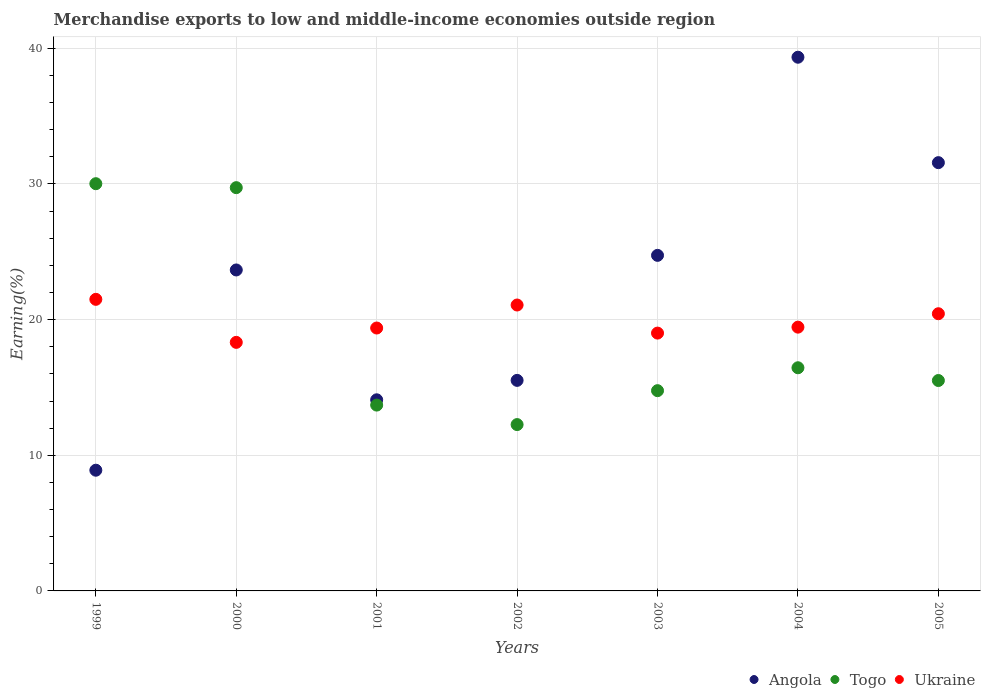How many different coloured dotlines are there?
Ensure brevity in your answer.  3. What is the percentage of amount earned from merchandise exports in Togo in 2002?
Offer a terse response. 12.26. Across all years, what is the maximum percentage of amount earned from merchandise exports in Togo?
Offer a very short reply. 30.02. Across all years, what is the minimum percentage of amount earned from merchandise exports in Togo?
Give a very brief answer. 12.26. In which year was the percentage of amount earned from merchandise exports in Togo minimum?
Give a very brief answer. 2002. What is the total percentage of amount earned from merchandise exports in Angola in the graph?
Make the answer very short. 157.82. What is the difference between the percentage of amount earned from merchandise exports in Togo in 2002 and that in 2003?
Offer a terse response. -2.5. What is the difference between the percentage of amount earned from merchandise exports in Ukraine in 2002 and the percentage of amount earned from merchandise exports in Togo in 2000?
Keep it short and to the point. -8.65. What is the average percentage of amount earned from merchandise exports in Angola per year?
Your response must be concise. 22.55. In the year 2005, what is the difference between the percentage of amount earned from merchandise exports in Angola and percentage of amount earned from merchandise exports in Ukraine?
Your answer should be compact. 11.14. In how many years, is the percentage of amount earned from merchandise exports in Togo greater than 18 %?
Your answer should be very brief. 2. What is the ratio of the percentage of amount earned from merchandise exports in Ukraine in 1999 to that in 2005?
Ensure brevity in your answer.  1.05. Is the percentage of amount earned from merchandise exports in Angola in 2000 less than that in 2002?
Provide a short and direct response. No. What is the difference between the highest and the second highest percentage of amount earned from merchandise exports in Togo?
Provide a short and direct response. 0.29. What is the difference between the highest and the lowest percentage of amount earned from merchandise exports in Ukraine?
Provide a succinct answer. 3.17. In how many years, is the percentage of amount earned from merchandise exports in Togo greater than the average percentage of amount earned from merchandise exports in Togo taken over all years?
Give a very brief answer. 2. Is it the case that in every year, the sum of the percentage of amount earned from merchandise exports in Togo and percentage of amount earned from merchandise exports in Ukraine  is greater than the percentage of amount earned from merchandise exports in Angola?
Give a very brief answer. No. Does the percentage of amount earned from merchandise exports in Ukraine monotonically increase over the years?
Your answer should be very brief. No. Is the percentage of amount earned from merchandise exports in Ukraine strictly greater than the percentage of amount earned from merchandise exports in Angola over the years?
Your answer should be very brief. No. Is the percentage of amount earned from merchandise exports in Angola strictly less than the percentage of amount earned from merchandise exports in Ukraine over the years?
Your answer should be compact. No. How many dotlines are there?
Your answer should be very brief. 3. How many years are there in the graph?
Offer a terse response. 7. What is the difference between two consecutive major ticks on the Y-axis?
Offer a very short reply. 10. How are the legend labels stacked?
Offer a very short reply. Horizontal. What is the title of the graph?
Keep it short and to the point. Merchandise exports to low and middle-income economies outside region. Does "East Asia (developing only)" appear as one of the legend labels in the graph?
Keep it short and to the point. No. What is the label or title of the X-axis?
Keep it short and to the point. Years. What is the label or title of the Y-axis?
Your answer should be compact. Earning(%). What is the Earning(%) in Angola in 1999?
Keep it short and to the point. 8.9. What is the Earning(%) of Togo in 1999?
Make the answer very short. 30.02. What is the Earning(%) in Ukraine in 1999?
Your answer should be very brief. 21.49. What is the Earning(%) of Angola in 2000?
Your response must be concise. 23.66. What is the Earning(%) in Togo in 2000?
Offer a terse response. 29.73. What is the Earning(%) in Ukraine in 2000?
Keep it short and to the point. 18.32. What is the Earning(%) in Angola in 2001?
Ensure brevity in your answer.  14.09. What is the Earning(%) in Togo in 2001?
Your answer should be very brief. 13.7. What is the Earning(%) of Ukraine in 2001?
Provide a succinct answer. 19.38. What is the Earning(%) in Angola in 2002?
Provide a succinct answer. 15.52. What is the Earning(%) in Togo in 2002?
Ensure brevity in your answer.  12.26. What is the Earning(%) of Ukraine in 2002?
Keep it short and to the point. 21.08. What is the Earning(%) of Angola in 2003?
Keep it short and to the point. 24.74. What is the Earning(%) of Togo in 2003?
Make the answer very short. 14.76. What is the Earning(%) in Ukraine in 2003?
Your answer should be compact. 19.01. What is the Earning(%) in Angola in 2004?
Provide a short and direct response. 39.34. What is the Earning(%) of Togo in 2004?
Provide a short and direct response. 16.45. What is the Earning(%) of Ukraine in 2004?
Give a very brief answer. 19.44. What is the Earning(%) of Angola in 2005?
Give a very brief answer. 31.57. What is the Earning(%) in Togo in 2005?
Keep it short and to the point. 15.51. What is the Earning(%) of Ukraine in 2005?
Ensure brevity in your answer.  20.43. Across all years, what is the maximum Earning(%) of Angola?
Offer a very short reply. 39.34. Across all years, what is the maximum Earning(%) of Togo?
Your answer should be compact. 30.02. Across all years, what is the maximum Earning(%) of Ukraine?
Provide a succinct answer. 21.49. Across all years, what is the minimum Earning(%) of Angola?
Your answer should be compact. 8.9. Across all years, what is the minimum Earning(%) in Togo?
Keep it short and to the point. 12.26. Across all years, what is the minimum Earning(%) in Ukraine?
Keep it short and to the point. 18.32. What is the total Earning(%) in Angola in the graph?
Your answer should be compact. 157.82. What is the total Earning(%) of Togo in the graph?
Keep it short and to the point. 132.43. What is the total Earning(%) of Ukraine in the graph?
Provide a succinct answer. 139.16. What is the difference between the Earning(%) in Angola in 1999 and that in 2000?
Offer a very short reply. -14.76. What is the difference between the Earning(%) of Togo in 1999 and that in 2000?
Ensure brevity in your answer.  0.29. What is the difference between the Earning(%) in Ukraine in 1999 and that in 2000?
Offer a terse response. 3.17. What is the difference between the Earning(%) of Angola in 1999 and that in 2001?
Make the answer very short. -5.19. What is the difference between the Earning(%) of Togo in 1999 and that in 2001?
Offer a very short reply. 16.32. What is the difference between the Earning(%) in Ukraine in 1999 and that in 2001?
Ensure brevity in your answer.  2.11. What is the difference between the Earning(%) of Angola in 1999 and that in 2002?
Ensure brevity in your answer.  -6.62. What is the difference between the Earning(%) in Togo in 1999 and that in 2002?
Your answer should be compact. 17.76. What is the difference between the Earning(%) in Ukraine in 1999 and that in 2002?
Offer a very short reply. 0.42. What is the difference between the Earning(%) of Angola in 1999 and that in 2003?
Ensure brevity in your answer.  -15.84. What is the difference between the Earning(%) in Togo in 1999 and that in 2003?
Give a very brief answer. 15.26. What is the difference between the Earning(%) in Ukraine in 1999 and that in 2003?
Ensure brevity in your answer.  2.49. What is the difference between the Earning(%) in Angola in 1999 and that in 2004?
Your answer should be very brief. -30.44. What is the difference between the Earning(%) in Togo in 1999 and that in 2004?
Give a very brief answer. 13.57. What is the difference between the Earning(%) in Ukraine in 1999 and that in 2004?
Ensure brevity in your answer.  2.05. What is the difference between the Earning(%) of Angola in 1999 and that in 2005?
Offer a terse response. -22.67. What is the difference between the Earning(%) of Togo in 1999 and that in 2005?
Give a very brief answer. 14.51. What is the difference between the Earning(%) in Ukraine in 1999 and that in 2005?
Ensure brevity in your answer.  1.06. What is the difference between the Earning(%) in Angola in 2000 and that in 2001?
Offer a very short reply. 9.57. What is the difference between the Earning(%) of Togo in 2000 and that in 2001?
Give a very brief answer. 16.03. What is the difference between the Earning(%) in Ukraine in 2000 and that in 2001?
Ensure brevity in your answer.  -1.06. What is the difference between the Earning(%) in Angola in 2000 and that in 2002?
Your answer should be very brief. 8.14. What is the difference between the Earning(%) of Togo in 2000 and that in 2002?
Your answer should be compact. 17.47. What is the difference between the Earning(%) in Ukraine in 2000 and that in 2002?
Make the answer very short. -2.75. What is the difference between the Earning(%) in Angola in 2000 and that in 2003?
Your response must be concise. -1.08. What is the difference between the Earning(%) of Togo in 2000 and that in 2003?
Offer a very short reply. 14.96. What is the difference between the Earning(%) of Ukraine in 2000 and that in 2003?
Provide a succinct answer. -0.68. What is the difference between the Earning(%) of Angola in 2000 and that in 2004?
Your response must be concise. -15.68. What is the difference between the Earning(%) in Togo in 2000 and that in 2004?
Provide a succinct answer. 13.28. What is the difference between the Earning(%) in Ukraine in 2000 and that in 2004?
Offer a terse response. -1.12. What is the difference between the Earning(%) in Angola in 2000 and that in 2005?
Provide a succinct answer. -7.91. What is the difference between the Earning(%) of Togo in 2000 and that in 2005?
Keep it short and to the point. 14.22. What is the difference between the Earning(%) of Ukraine in 2000 and that in 2005?
Make the answer very short. -2.11. What is the difference between the Earning(%) in Angola in 2001 and that in 2002?
Your answer should be very brief. -1.43. What is the difference between the Earning(%) in Togo in 2001 and that in 2002?
Keep it short and to the point. 1.44. What is the difference between the Earning(%) of Ukraine in 2001 and that in 2002?
Ensure brevity in your answer.  -1.7. What is the difference between the Earning(%) in Angola in 2001 and that in 2003?
Provide a short and direct response. -10.65. What is the difference between the Earning(%) in Togo in 2001 and that in 2003?
Give a very brief answer. -1.06. What is the difference between the Earning(%) in Ukraine in 2001 and that in 2003?
Offer a terse response. 0.37. What is the difference between the Earning(%) in Angola in 2001 and that in 2004?
Offer a terse response. -25.25. What is the difference between the Earning(%) in Togo in 2001 and that in 2004?
Your answer should be very brief. -2.75. What is the difference between the Earning(%) of Ukraine in 2001 and that in 2004?
Your answer should be compact. -0.06. What is the difference between the Earning(%) of Angola in 2001 and that in 2005?
Provide a succinct answer. -17.48. What is the difference between the Earning(%) in Togo in 2001 and that in 2005?
Offer a terse response. -1.81. What is the difference between the Earning(%) in Ukraine in 2001 and that in 2005?
Provide a succinct answer. -1.05. What is the difference between the Earning(%) in Angola in 2002 and that in 2003?
Your response must be concise. -9.22. What is the difference between the Earning(%) in Togo in 2002 and that in 2003?
Give a very brief answer. -2.5. What is the difference between the Earning(%) in Ukraine in 2002 and that in 2003?
Your answer should be compact. 2.07. What is the difference between the Earning(%) in Angola in 2002 and that in 2004?
Offer a terse response. -23.82. What is the difference between the Earning(%) of Togo in 2002 and that in 2004?
Provide a succinct answer. -4.19. What is the difference between the Earning(%) of Ukraine in 2002 and that in 2004?
Your answer should be compact. 1.63. What is the difference between the Earning(%) of Angola in 2002 and that in 2005?
Offer a very short reply. -16.05. What is the difference between the Earning(%) in Togo in 2002 and that in 2005?
Your answer should be compact. -3.25. What is the difference between the Earning(%) in Ukraine in 2002 and that in 2005?
Ensure brevity in your answer.  0.64. What is the difference between the Earning(%) of Angola in 2003 and that in 2004?
Your response must be concise. -14.61. What is the difference between the Earning(%) in Togo in 2003 and that in 2004?
Provide a short and direct response. -1.69. What is the difference between the Earning(%) in Ukraine in 2003 and that in 2004?
Provide a succinct answer. -0.44. What is the difference between the Earning(%) of Angola in 2003 and that in 2005?
Your answer should be compact. -6.83. What is the difference between the Earning(%) in Togo in 2003 and that in 2005?
Provide a succinct answer. -0.75. What is the difference between the Earning(%) of Ukraine in 2003 and that in 2005?
Keep it short and to the point. -1.43. What is the difference between the Earning(%) of Angola in 2004 and that in 2005?
Keep it short and to the point. 7.77. What is the difference between the Earning(%) of Togo in 2004 and that in 2005?
Keep it short and to the point. 0.94. What is the difference between the Earning(%) of Ukraine in 2004 and that in 2005?
Offer a very short reply. -0.99. What is the difference between the Earning(%) in Angola in 1999 and the Earning(%) in Togo in 2000?
Provide a succinct answer. -20.83. What is the difference between the Earning(%) in Angola in 1999 and the Earning(%) in Ukraine in 2000?
Your response must be concise. -9.42. What is the difference between the Earning(%) of Togo in 1999 and the Earning(%) of Ukraine in 2000?
Offer a very short reply. 11.7. What is the difference between the Earning(%) of Angola in 1999 and the Earning(%) of Togo in 2001?
Your response must be concise. -4.8. What is the difference between the Earning(%) of Angola in 1999 and the Earning(%) of Ukraine in 2001?
Your response must be concise. -10.48. What is the difference between the Earning(%) of Togo in 1999 and the Earning(%) of Ukraine in 2001?
Your response must be concise. 10.64. What is the difference between the Earning(%) of Angola in 1999 and the Earning(%) of Togo in 2002?
Make the answer very short. -3.36. What is the difference between the Earning(%) of Angola in 1999 and the Earning(%) of Ukraine in 2002?
Your response must be concise. -12.18. What is the difference between the Earning(%) of Togo in 1999 and the Earning(%) of Ukraine in 2002?
Provide a succinct answer. 8.94. What is the difference between the Earning(%) in Angola in 1999 and the Earning(%) in Togo in 2003?
Offer a terse response. -5.86. What is the difference between the Earning(%) in Angola in 1999 and the Earning(%) in Ukraine in 2003?
Provide a short and direct response. -10.11. What is the difference between the Earning(%) of Togo in 1999 and the Earning(%) of Ukraine in 2003?
Your answer should be compact. 11.01. What is the difference between the Earning(%) of Angola in 1999 and the Earning(%) of Togo in 2004?
Your answer should be compact. -7.55. What is the difference between the Earning(%) of Angola in 1999 and the Earning(%) of Ukraine in 2004?
Your response must be concise. -10.55. What is the difference between the Earning(%) in Togo in 1999 and the Earning(%) in Ukraine in 2004?
Make the answer very short. 10.57. What is the difference between the Earning(%) of Angola in 1999 and the Earning(%) of Togo in 2005?
Keep it short and to the point. -6.61. What is the difference between the Earning(%) in Angola in 1999 and the Earning(%) in Ukraine in 2005?
Your answer should be compact. -11.54. What is the difference between the Earning(%) in Togo in 1999 and the Earning(%) in Ukraine in 2005?
Your response must be concise. 9.59. What is the difference between the Earning(%) in Angola in 2000 and the Earning(%) in Togo in 2001?
Offer a terse response. 9.96. What is the difference between the Earning(%) in Angola in 2000 and the Earning(%) in Ukraine in 2001?
Keep it short and to the point. 4.28. What is the difference between the Earning(%) of Togo in 2000 and the Earning(%) of Ukraine in 2001?
Your answer should be compact. 10.35. What is the difference between the Earning(%) of Angola in 2000 and the Earning(%) of Togo in 2002?
Your response must be concise. 11.4. What is the difference between the Earning(%) of Angola in 2000 and the Earning(%) of Ukraine in 2002?
Your answer should be compact. 2.58. What is the difference between the Earning(%) of Togo in 2000 and the Earning(%) of Ukraine in 2002?
Keep it short and to the point. 8.65. What is the difference between the Earning(%) of Angola in 2000 and the Earning(%) of Togo in 2003?
Make the answer very short. 8.9. What is the difference between the Earning(%) of Angola in 2000 and the Earning(%) of Ukraine in 2003?
Give a very brief answer. 4.65. What is the difference between the Earning(%) of Togo in 2000 and the Earning(%) of Ukraine in 2003?
Offer a terse response. 10.72. What is the difference between the Earning(%) in Angola in 2000 and the Earning(%) in Togo in 2004?
Give a very brief answer. 7.21. What is the difference between the Earning(%) of Angola in 2000 and the Earning(%) of Ukraine in 2004?
Your answer should be very brief. 4.22. What is the difference between the Earning(%) in Togo in 2000 and the Earning(%) in Ukraine in 2004?
Provide a short and direct response. 10.28. What is the difference between the Earning(%) in Angola in 2000 and the Earning(%) in Togo in 2005?
Your answer should be very brief. 8.15. What is the difference between the Earning(%) of Angola in 2000 and the Earning(%) of Ukraine in 2005?
Offer a very short reply. 3.23. What is the difference between the Earning(%) of Togo in 2000 and the Earning(%) of Ukraine in 2005?
Provide a succinct answer. 9.29. What is the difference between the Earning(%) of Angola in 2001 and the Earning(%) of Togo in 2002?
Provide a short and direct response. 1.83. What is the difference between the Earning(%) in Angola in 2001 and the Earning(%) in Ukraine in 2002?
Provide a succinct answer. -6.99. What is the difference between the Earning(%) of Togo in 2001 and the Earning(%) of Ukraine in 2002?
Offer a terse response. -7.38. What is the difference between the Earning(%) in Angola in 2001 and the Earning(%) in Togo in 2003?
Keep it short and to the point. -0.67. What is the difference between the Earning(%) of Angola in 2001 and the Earning(%) of Ukraine in 2003?
Offer a very short reply. -4.92. What is the difference between the Earning(%) in Togo in 2001 and the Earning(%) in Ukraine in 2003?
Your answer should be compact. -5.31. What is the difference between the Earning(%) in Angola in 2001 and the Earning(%) in Togo in 2004?
Keep it short and to the point. -2.36. What is the difference between the Earning(%) of Angola in 2001 and the Earning(%) of Ukraine in 2004?
Ensure brevity in your answer.  -5.36. What is the difference between the Earning(%) of Togo in 2001 and the Earning(%) of Ukraine in 2004?
Ensure brevity in your answer.  -5.75. What is the difference between the Earning(%) of Angola in 2001 and the Earning(%) of Togo in 2005?
Offer a very short reply. -1.42. What is the difference between the Earning(%) in Angola in 2001 and the Earning(%) in Ukraine in 2005?
Give a very brief answer. -6.34. What is the difference between the Earning(%) in Togo in 2001 and the Earning(%) in Ukraine in 2005?
Your answer should be compact. -6.73. What is the difference between the Earning(%) of Angola in 2002 and the Earning(%) of Togo in 2003?
Provide a succinct answer. 0.76. What is the difference between the Earning(%) of Angola in 2002 and the Earning(%) of Ukraine in 2003?
Keep it short and to the point. -3.49. What is the difference between the Earning(%) of Togo in 2002 and the Earning(%) of Ukraine in 2003?
Keep it short and to the point. -6.74. What is the difference between the Earning(%) of Angola in 2002 and the Earning(%) of Togo in 2004?
Keep it short and to the point. -0.93. What is the difference between the Earning(%) of Angola in 2002 and the Earning(%) of Ukraine in 2004?
Your answer should be compact. -3.92. What is the difference between the Earning(%) of Togo in 2002 and the Earning(%) of Ukraine in 2004?
Give a very brief answer. -7.18. What is the difference between the Earning(%) in Angola in 2002 and the Earning(%) in Togo in 2005?
Provide a succinct answer. 0.01. What is the difference between the Earning(%) in Angola in 2002 and the Earning(%) in Ukraine in 2005?
Offer a very short reply. -4.91. What is the difference between the Earning(%) in Togo in 2002 and the Earning(%) in Ukraine in 2005?
Your answer should be compact. -8.17. What is the difference between the Earning(%) in Angola in 2003 and the Earning(%) in Togo in 2004?
Offer a very short reply. 8.29. What is the difference between the Earning(%) in Angola in 2003 and the Earning(%) in Ukraine in 2004?
Offer a terse response. 5.29. What is the difference between the Earning(%) of Togo in 2003 and the Earning(%) of Ukraine in 2004?
Keep it short and to the point. -4.68. What is the difference between the Earning(%) of Angola in 2003 and the Earning(%) of Togo in 2005?
Offer a terse response. 9.23. What is the difference between the Earning(%) of Angola in 2003 and the Earning(%) of Ukraine in 2005?
Provide a short and direct response. 4.3. What is the difference between the Earning(%) in Togo in 2003 and the Earning(%) in Ukraine in 2005?
Ensure brevity in your answer.  -5.67. What is the difference between the Earning(%) of Angola in 2004 and the Earning(%) of Togo in 2005?
Your response must be concise. 23.83. What is the difference between the Earning(%) in Angola in 2004 and the Earning(%) in Ukraine in 2005?
Make the answer very short. 18.91. What is the difference between the Earning(%) of Togo in 2004 and the Earning(%) of Ukraine in 2005?
Keep it short and to the point. -3.98. What is the average Earning(%) in Angola per year?
Provide a short and direct response. 22.55. What is the average Earning(%) of Togo per year?
Offer a very short reply. 18.92. What is the average Earning(%) in Ukraine per year?
Keep it short and to the point. 19.88. In the year 1999, what is the difference between the Earning(%) in Angola and Earning(%) in Togo?
Your response must be concise. -21.12. In the year 1999, what is the difference between the Earning(%) of Angola and Earning(%) of Ukraine?
Offer a terse response. -12.6. In the year 1999, what is the difference between the Earning(%) of Togo and Earning(%) of Ukraine?
Your answer should be compact. 8.52. In the year 2000, what is the difference between the Earning(%) of Angola and Earning(%) of Togo?
Your response must be concise. -6.07. In the year 2000, what is the difference between the Earning(%) in Angola and Earning(%) in Ukraine?
Keep it short and to the point. 5.34. In the year 2000, what is the difference between the Earning(%) in Togo and Earning(%) in Ukraine?
Provide a succinct answer. 11.4. In the year 2001, what is the difference between the Earning(%) of Angola and Earning(%) of Togo?
Your answer should be compact. 0.39. In the year 2001, what is the difference between the Earning(%) in Angola and Earning(%) in Ukraine?
Offer a very short reply. -5.29. In the year 2001, what is the difference between the Earning(%) in Togo and Earning(%) in Ukraine?
Ensure brevity in your answer.  -5.68. In the year 2002, what is the difference between the Earning(%) of Angola and Earning(%) of Togo?
Make the answer very short. 3.26. In the year 2002, what is the difference between the Earning(%) in Angola and Earning(%) in Ukraine?
Provide a short and direct response. -5.56. In the year 2002, what is the difference between the Earning(%) in Togo and Earning(%) in Ukraine?
Keep it short and to the point. -8.81. In the year 2003, what is the difference between the Earning(%) of Angola and Earning(%) of Togo?
Keep it short and to the point. 9.97. In the year 2003, what is the difference between the Earning(%) of Angola and Earning(%) of Ukraine?
Your answer should be compact. 5.73. In the year 2003, what is the difference between the Earning(%) of Togo and Earning(%) of Ukraine?
Your answer should be very brief. -4.24. In the year 2004, what is the difference between the Earning(%) of Angola and Earning(%) of Togo?
Provide a succinct answer. 22.89. In the year 2004, what is the difference between the Earning(%) in Angola and Earning(%) in Ukraine?
Offer a very short reply. 19.9. In the year 2004, what is the difference between the Earning(%) in Togo and Earning(%) in Ukraine?
Keep it short and to the point. -2.99. In the year 2005, what is the difference between the Earning(%) of Angola and Earning(%) of Togo?
Offer a terse response. 16.06. In the year 2005, what is the difference between the Earning(%) of Angola and Earning(%) of Ukraine?
Your response must be concise. 11.14. In the year 2005, what is the difference between the Earning(%) in Togo and Earning(%) in Ukraine?
Your answer should be compact. -4.92. What is the ratio of the Earning(%) in Angola in 1999 to that in 2000?
Provide a short and direct response. 0.38. What is the ratio of the Earning(%) in Togo in 1999 to that in 2000?
Your response must be concise. 1.01. What is the ratio of the Earning(%) in Ukraine in 1999 to that in 2000?
Give a very brief answer. 1.17. What is the ratio of the Earning(%) of Angola in 1999 to that in 2001?
Offer a terse response. 0.63. What is the ratio of the Earning(%) in Togo in 1999 to that in 2001?
Offer a very short reply. 2.19. What is the ratio of the Earning(%) in Ukraine in 1999 to that in 2001?
Keep it short and to the point. 1.11. What is the ratio of the Earning(%) of Angola in 1999 to that in 2002?
Ensure brevity in your answer.  0.57. What is the ratio of the Earning(%) of Togo in 1999 to that in 2002?
Make the answer very short. 2.45. What is the ratio of the Earning(%) in Ukraine in 1999 to that in 2002?
Offer a very short reply. 1.02. What is the ratio of the Earning(%) in Angola in 1999 to that in 2003?
Ensure brevity in your answer.  0.36. What is the ratio of the Earning(%) of Togo in 1999 to that in 2003?
Your answer should be compact. 2.03. What is the ratio of the Earning(%) of Ukraine in 1999 to that in 2003?
Offer a very short reply. 1.13. What is the ratio of the Earning(%) of Angola in 1999 to that in 2004?
Your response must be concise. 0.23. What is the ratio of the Earning(%) in Togo in 1999 to that in 2004?
Give a very brief answer. 1.82. What is the ratio of the Earning(%) in Ukraine in 1999 to that in 2004?
Keep it short and to the point. 1.11. What is the ratio of the Earning(%) of Angola in 1999 to that in 2005?
Your response must be concise. 0.28. What is the ratio of the Earning(%) of Togo in 1999 to that in 2005?
Offer a very short reply. 1.94. What is the ratio of the Earning(%) in Ukraine in 1999 to that in 2005?
Offer a very short reply. 1.05. What is the ratio of the Earning(%) of Angola in 2000 to that in 2001?
Your answer should be compact. 1.68. What is the ratio of the Earning(%) in Togo in 2000 to that in 2001?
Provide a short and direct response. 2.17. What is the ratio of the Earning(%) of Ukraine in 2000 to that in 2001?
Your response must be concise. 0.95. What is the ratio of the Earning(%) in Angola in 2000 to that in 2002?
Offer a terse response. 1.52. What is the ratio of the Earning(%) in Togo in 2000 to that in 2002?
Offer a very short reply. 2.42. What is the ratio of the Earning(%) in Ukraine in 2000 to that in 2002?
Provide a short and direct response. 0.87. What is the ratio of the Earning(%) in Angola in 2000 to that in 2003?
Your response must be concise. 0.96. What is the ratio of the Earning(%) of Togo in 2000 to that in 2003?
Give a very brief answer. 2.01. What is the ratio of the Earning(%) of Ukraine in 2000 to that in 2003?
Ensure brevity in your answer.  0.96. What is the ratio of the Earning(%) in Angola in 2000 to that in 2004?
Give a very brief answer. 0.6. What is the ratio of the Earning(%) in Togo in 2000 to that in 2004?
Keep it short and to the point. 1.81. What is the ratio of the Earning(%) in Ukraine in 2000 to that in 2004?
Provide a succinct answer. 0.94. What is the ratio of the Earning(%) in Angola in 2000 to that in 2005?
Keep it short and to the point. 0.75. What is the ratio of the Earning(%) in Togo in 2000 to that in 2005?
Your answer should be compact. 1.92. What is the ratio of the Earning(%) in Ukraine in 2000 to that in 2005?
Offer a terse response. 0.9. What is the ratio of the Earning(%) of Angola in 2001 to that in 2002?
Make the answer very short. 0.91. What is the ratio of the Earning(%) in Togo in 2001 to that in 2002?
Offer a terse response. 1.12. What is the ratio of the Earning(%) of Ukraine in 2001 to that in 2002?
Give a very brief answer. 0.92. What is the ratio of the Earning(%) of Angola in 2001 to that in 2003?
Your answer should be compact. 0.57. What is the ratio of the Earning(%) in Togo in 2001 to that in 2003?
Your answer should be compact. 0.93. What is the ratio of the Earning(%) in Ukraine in 2001 to that in 2003?
Give a very brief answer. 1.02. What is the ratio of the Earning(%) of Angola in 2001 to that in 2004?
Keep it short and to the point. 0.36. What is the ratio of the Earning(%) of Togo in 2001 to that in 2004?
Keep it short and to the point. 0.83. What is the ratio of the Earning(%) of Ukraine in 2001 to that in 2004?
Your answer should be compact. 1. What is the ratio of the Earning(%) of Angola in 2001 to that in 2005?
Make the answer very short. 0.45. What is the ratio of the Earning(%) of Togo in 2001 to that in 2005?
Offer a terse response. 0.88. What is the ratio of the Earning(%) of Ukraine in 2001 to that in 2005?
Make the answer very short. 0.95. What is the ratio of the Earning(%) of Angola in 2002 to that in 2003?
Keep it short and to the point. 0.63. What is the ratio of the Earning(%) of Togo in 2002 to that in 2003?
Make the answer very short. 0.83. What is the ratio of the Earning(%) in Ukraine in 2002 to that in 2003?
Make the answer very short. 1.11. What is the ratio of the Earning(%) in Angola in 2002 to that in 2004?
Your answer should be very brief. 0.39. What is the ratio of the Earning(%) of Togo in 2002 to that in 2004?
Make the answer very short. 0.75. What is the ratio of the Earning(%) of Ukraine in 2002 to that in 2004?
Your answer should be compact. 1.08. What is the ratio of the Earning(%) of Angola in 2002 to that in 2005?
Keep it short and to the point. 0.49. What is the ratio of the Earning(%) of Togo in 2002 to that in 2005?
Keep it short and to the point. 0.79. What is the ratio of the Earning(%) of Ukraine in 2002 to that in 2005?
Provide a succinct answer. 1.03. What is the ratio of the Earning(%) in Angola in 2003 to that in 2004?
Your answer should be compact. 0.63. What is the ratio of the Earning(%) of Togo in 2003 to that in 2004?
Offer a very short reply. 0.9. What is the ratio of the Earning(%) in Ukraine in 2003 to that in 2004?
Ensure brevity in your answer.  0.98. What is the ratio of the Earning(%) of Angola in 2003 to that in 2005?
Keep it short and to the point. 0.78. What is the ratio of the Earning(%) of Togo in 2003 to that in 2005?
Offer a terse response. 0.95. What is the ratio of the Earning(%) in Ukraine in 2003 to that in 2005?
Keep it short and to the point. 0.93. What is the ratio of the Earning(%) of Angola in 2004 to that in 2005?
Provide a short and direct response. 1.25. What is the ratio of the Earning(%) in Togo in 2004 to that in 2005?
Keep it short and to the point. 1.06. What is the ratio of the Earning(%) in Ukraine in 2004 to that in 2005?
Give a very brief answer. 0.95. What is the difference between the highest and the second highest Earning(%) of Angola?
Ensure brevity in your answer.  7.77. What is the difference between the highest and the second highest Earning(%) in Togo?
Your answer should be compact. 0.29. What is the difference between the highest and the second highest Earning(%) in Ukraine?
Give a very brief answer. 0.42. What is the difference between the highest and the lowest Earning(%) of Angola?
Your answer should be very brief. 30.44. What is the difference between the highest and the lowest Earning(%) of Togo?
Your response must be concise. 17.76. What is the difference between the highest and the lowest Earning(%) of Ukraine?
Your answer should be compact. 3.17. 